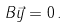Convert formula to latex. <formula><loc_0><loc_0><loc_500><loc_500>B \vec { y } = 0 \, .</formula> 